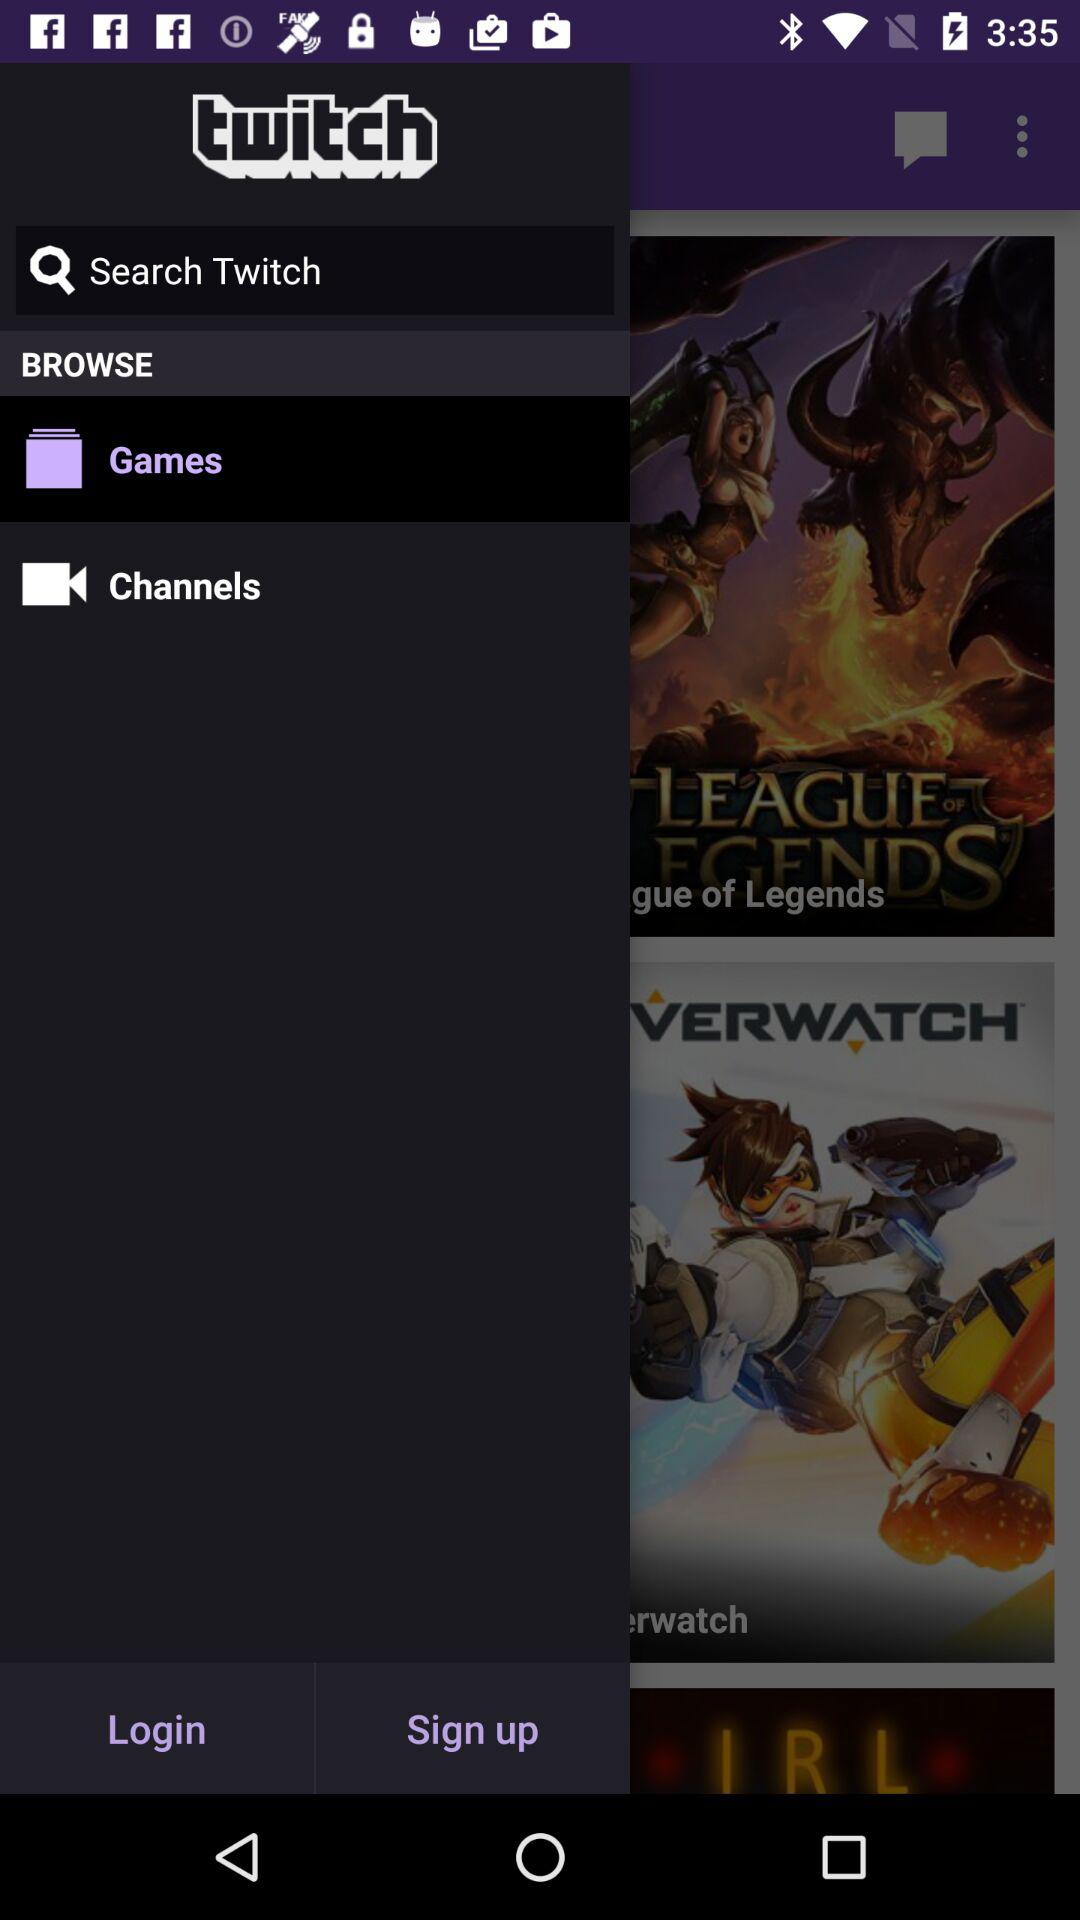When was "twitch" copyrighted?
When the provided information is insufficient, respond with <no answer>. <no answer> 